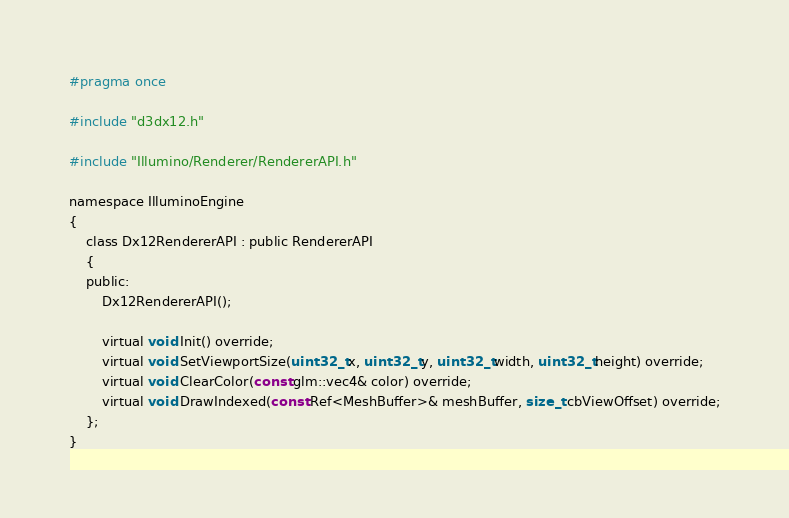Convert code to text. <code><loc_0><loc_0><loc_500><loc_500><_C_>#pragma once

#include "d3dx12.h"

#include "Illumino/Renderer/RendererAPI.h"

namespace IlluminoEngine
{
	class Dx12RendererAPI : public RendererAPI
	{
	public:
		Dx12RendererAPI();

		virtual void Init() override;
		virtual void SetViewportSize(uint32_t x, uint32_t y, uint32_t width, uint32_t height) override;
		virtual void ClearColor(const glm::vec4& color) override;
		virtual void DrawIndexed(const Ref<MeshBuffer>& meshBuffer, size_t cbViewOffset) override;
	};
}
</code> 